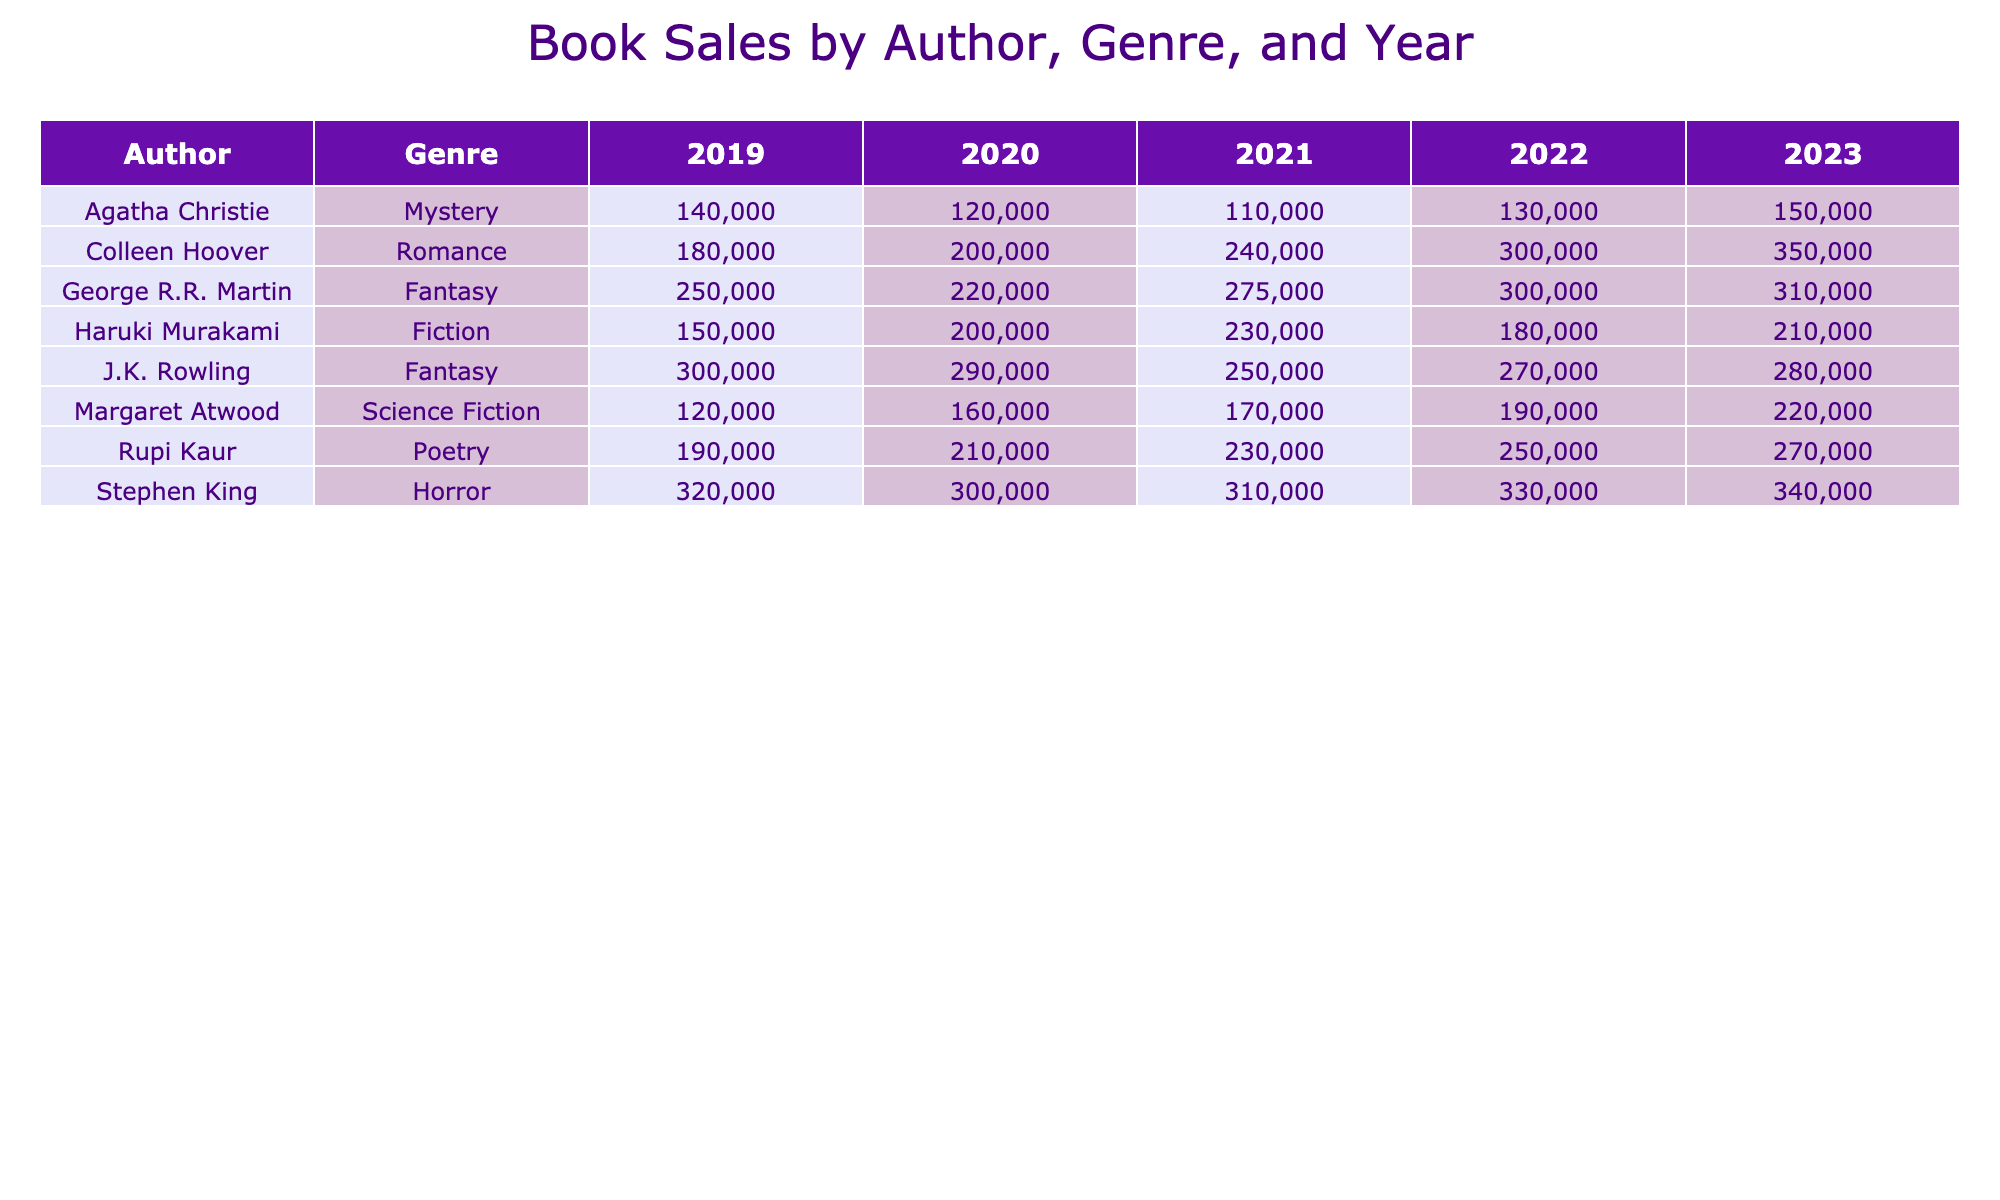What were the book sales of Haruki Murakami in 2020? Looking at the row for Haruki Murakami under the Fiction genre for the year 2020, the sales figure is 200,000.
Answer: 200,000 What is the total sales of Colleen Hoover over the five years? To find the total, sum up the yearly sales: 180000 + 200000 + 240000 + 300000 + 350000 = 1270000.
Answer: 1,270,000 Did Stephen King have sales greater than 300,000 in every year? Checking Stephen King's sales for each year: 320000, 300000, 310000, 330000, and 340000 shows that the sales were greater than or equal to 300,000 each year.
Answer: Yes Which genre had the highest sales from George R.R. Martin in 2021? In 2021, George R.R. Martin's sales in the Fantasy genre were 275,000, which was the only genre he is listed for. Thus, it is also the highest.
Answer: Fantasy What was the average sales for Rupi Kaur across all years? To calculate the average, take the total sales: 190000 + 210000 + 230000 + 250000 + 270000 = 1150000. Then divide by the number of years (5): 1150000 / 5 = 230000.
Answer: 230,000 Which author had the highest single-year sales and in what year? The highest single-year sales figure is for J.K. Rowling in 2019, with sales of 300,000.
Answer: J.K. Rowling, 2019 What was the trend in sales for Margaret Atwood from 2019 to 2023? By examining the yearly sales from the table, Margaret Atwood's sales increased from 120,000 in 2019 to 220,000 in 2023, indicating an upward trend.
Answer: Upward trend What is the difference in sales between Agatha Christie in 2019 and 2023? Agatha Christie had sales of 140,000 in 2019 and 150,000 in 2023. The difference is calculated as: 150000 - 140000 = 10000.
Answer: 10,000 Which genre saw the most significant increase in sales from 2019 to 2022? To determine this, observe the largest increase: For Colleen Hoover (Romance), sales rose from 180,000 in 2019 to 300,000 in 2022, an increase of 120,000. This is greater than any other genre's increase.
Answer: Romance Was there a year when the sales of any author exceeded 350,000? Looking through the data, no author has sales exceeding 350,000 in any year, as the maximum is 350,000 by Colleen Hoover in 2023.
Answer: No 